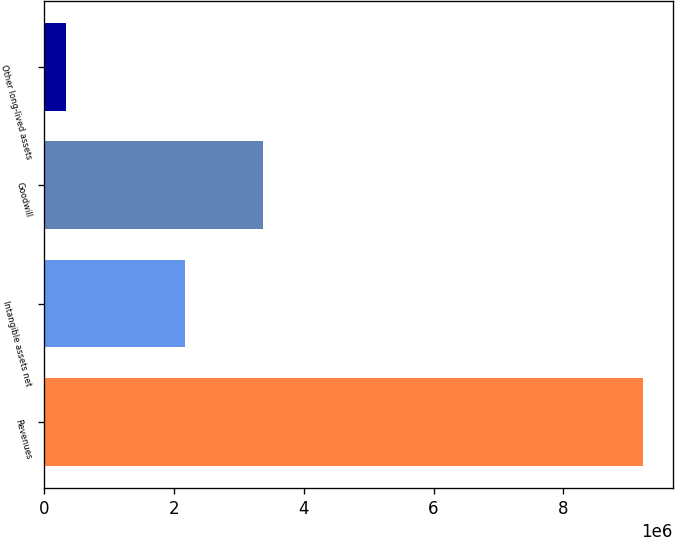Convert chart to OTSL. <chart><loc_0><loc_0><loc_500><loc_500><bar_chart><fcel>Revenues<fcel>Intangible assets net<fcel>Goodwill<fcel>Other long-lived assets<nl><fcel>9.22399e+06<fcel>2.16753e+06<fcel>3.375e+06<fcel>331127<nl></chart> 